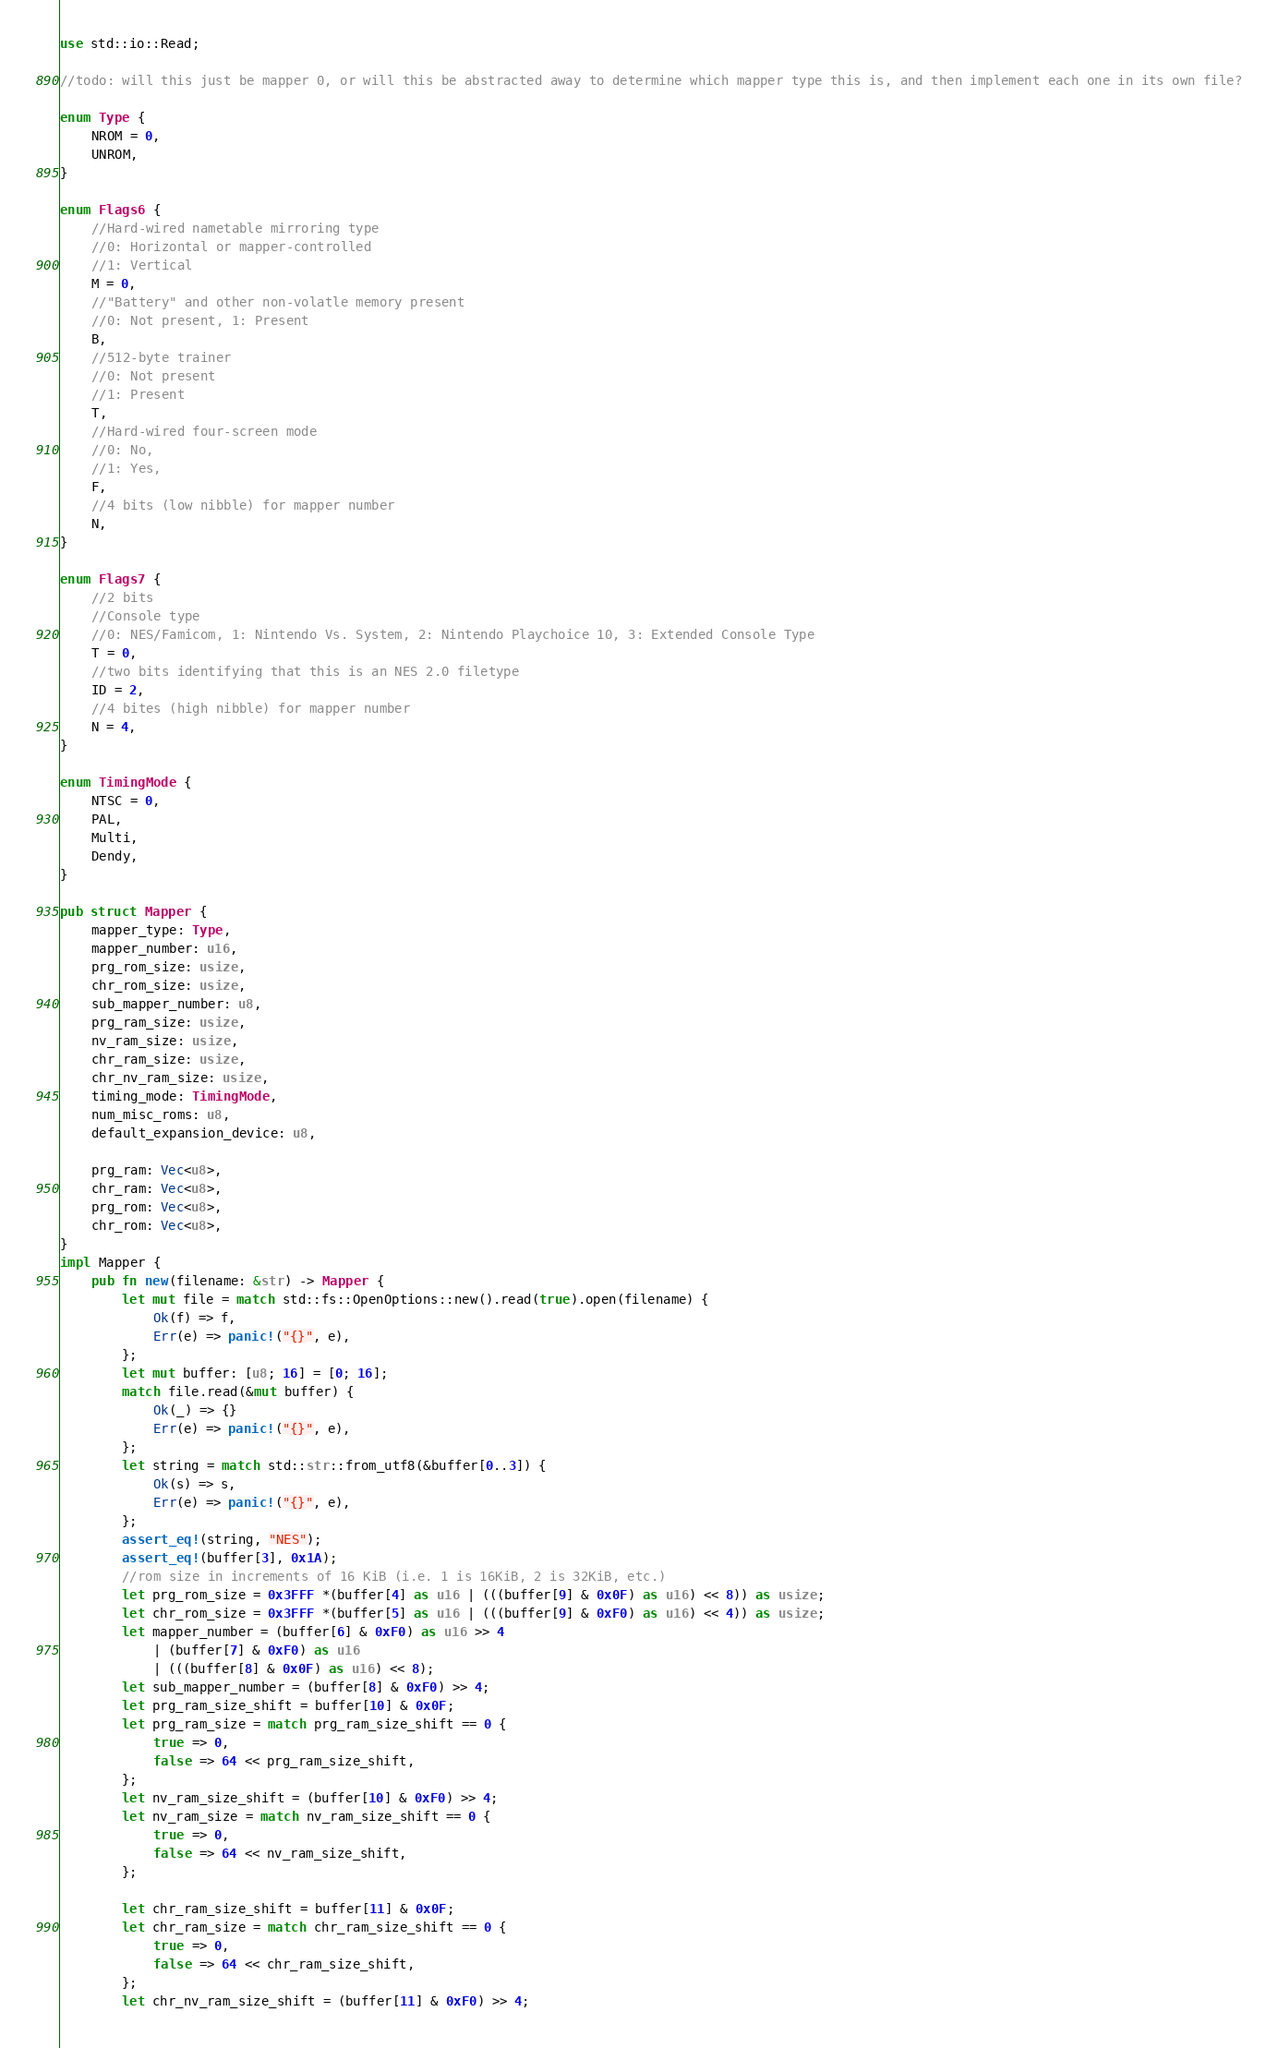Convert code to text. <code><loc_0><loc_0><loc_500><loc_500><_Rust_>use std::io::Read;

//todo: will this just be mapper 0, or will this be abstracted away to determine which mapper type this is, and then implement each one in its own file?

enum Type {
    NROM = 0,
    UNROM,
}

enum Flags6 {
    //Hard-wired nametable mirroring type
    //0: Horizontal or mapper-controlled
    //1: Vertical
    M = 0,
    //"Battery" and other non-volatle memory present
    //0: Not present, 1: Present
    B,
    //512-byte trainer
    //0: Not present
    //1: Present
    T,
    //Hard-wired four-screen mode
    //0: No,
    //1: Yes,
    F,
    //4 bits (low nibble) for mapper number
    N,
}

enum Flags7 {
    //2 bits
    //Console type
    //0: NES/Famicom, 1: Nintendo Vs. System, 2: Nintendo Playchoice 10, 3: Extended Console Type
    T = 0,
    //two bits identifying that this is an NES 2.0 filetype
    ID = 2,
    //4 bites (high nibble) for mapper number
    N = 4,
}

enum TimingMode {
    NTSC = 0,
    PAL,
    Multi,
    Dendy,
}

pub struct Mapper {
    mapper_type: Type,
    mapper_number: u16,
    prg_rom_size: usize,
    chr_rom_size: usize,
    sub_mapper_number: u8,
    prg_ram_size: usize,
    nv_ram_size: usize,
    chr_ram_size: usize,
    chr_nv_ram_size: usize,
    timing_mode: TimingMode,
    num_misc_roms: u8,
    default_expansion_device: u8,

    prg_ram: Vec<u8>,
    chr_ram: Vec<u8>,
    prg_rom: Vec<u8>,
    chr_rom: Vec<u8>,
}
impl Mapper {
    pub fn new(filename: &str) -> Mapper {
        let mut file = match std::fs::OpenOptions::new().read(true).open(filename) {
            Ok(f) => f,
            Err(e) => panic!("{}", e),
        };
        let mut buffer: [u8; 16] = [0; 16];
        match file.read(&mut buffer) {
            Ok(_) => {}
            Err(e) => panic!("{}", e),
        };
        let string = match std::str::from_utf8(&buffer[0..3]) {
            Ok(s) => s,
            Err(e) => panic!("{}", e),
        };
        assert_eq!(string, "NES");
		assert_eq!(buffer[3], 0x1A);
		//rom size in increments of 16 KiB (i.e. 1 is 16KiB, 2 is 32KiB, etc.)
        let prg_rom_size = 0x3FFF *(buffer[4] as u16 | (((buffer[9] & 0x0F) as u16) << 8)) as usize;
        let chr_rom_size = 0x3FFF *(buffer[5] as u16 | (((buffer[9] & 0xF0) as u16) << 4)) as usize;
        let mapper_number = (buffer[6] & 0xF0) as u16 >> 4
            | (buffer[7] & 0xF0) as u16
			| (((buffer[8] & 0x0F) as u16) << 8);
        let sub_mapper_number = (buffer[8] & 0xF0) >> 4;
        let prg_ram_size_shift = buffer[10] & 0x0F;
        let prg_ram_size = match prg_ram_size_shift == 0 {
            true => 0,
            false => 64 << prg_ram_size_shift,
        };
        let nv_ram_size_shift = (buffer[10] & 0xF0) >> 4;
        let nv_ram_size = match nv_ram_size_shift == 0 {
            true => 0,
            false => 64 << nv_ram_size_shift,
        };

        let chr_ram_size_shift = buffer[11] & 0x0F;
        let chr_ram_size = match chr_ram_size_shift == 0 {
            true => 0,
            false => 64 << chr_ram_size_shift,
        };
        let chr_nv_ram_size_shift = (buffer[11] & 0xF0) >> 4;</code> 